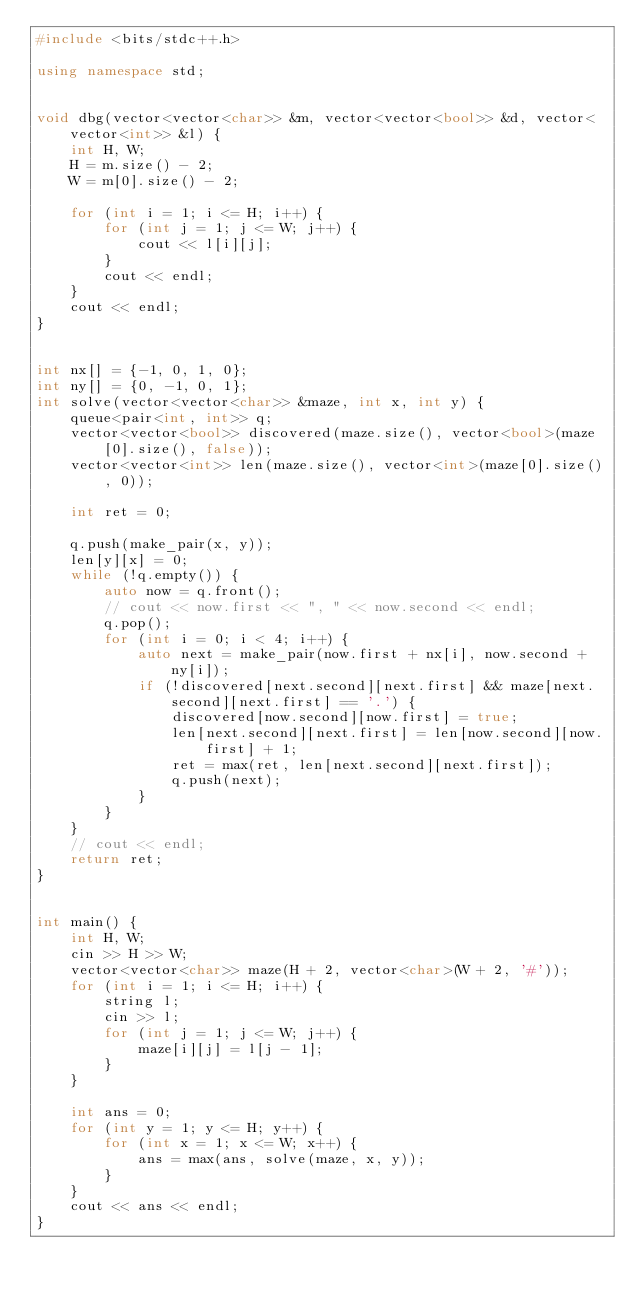Convert code to text. <code><loc_0><loc_0><loc_500><loc_500><_C++_>#include <bits/stdc++.h>

using namespace std;


void dbg(vector<vector<char>> &m, vector<vector<bool>> &d, vector<vector<int>> &l) {
    int H, W;
    H = m.size() - 2;
    W = m[0].size() - 2;

    for (int i = 1; i <= H; i++) {
        for (int j = 1; j <= W; j++) {
            cout << l[i][j];
        }
        cout << endl;
    }
    cout << endl;
}


int nx[] = {-1, 0, 1, 0};
int ny[] = {0, -1, 0, 1};
int solve(vector<vector<char>> &maze, int x, int y) {
    queue<pair<int, int>> q;
    vector<vector<bool>> discovered(maze.size(), vector<bool>(maze[0].size(), false));
    vector<vector<int>> len(maze.size(), vector<int>(maze[0].size(), 0));

    int ret = 0;

    q.push(make_pair(x, y));
    len[y][x] = 0;
    while (!q.empty()) {
        auto now = q.front();
        // cout << now.first << ", " << now.second << endl;
        q.pop();
        for (int i = 0; i < 4; i++) {
            auto next = make_pair(now.first + nx[i], now.second + ny[i]);
            if (!discovered[next.second][next.first] && maze[next.second][next.first] == '.') {
                discovered[now.second][now.first] = true;
                len[next.second][next.first] = len[now.second][now.first] + 1;
                ret = max(ret, len[next.second][next.first]);
                q.push(next);
            }
        }
    }
    // cout << endl;
    return ret;
}


int main() {
    int H, W;
    cin >> H >> W;
    vector<vector<char>> maze(H + 2, vector<char>(W + 2, '#'));
    for (int i = 1; i <= H; i++) {
        string l;
        cin >> l;
        for (int j = 1; j <= W; j++) {
            maze[i][j] = l[j - 1];
        }
    }

    int ans = 0;
    for (int y = 1; y <= H; y++) {
        for (int x = 1; x <= W; x++) {
            ans = max(ans, solve(maze, x, y));
        }
    }
    cout << ans << endl;
}
</code> 